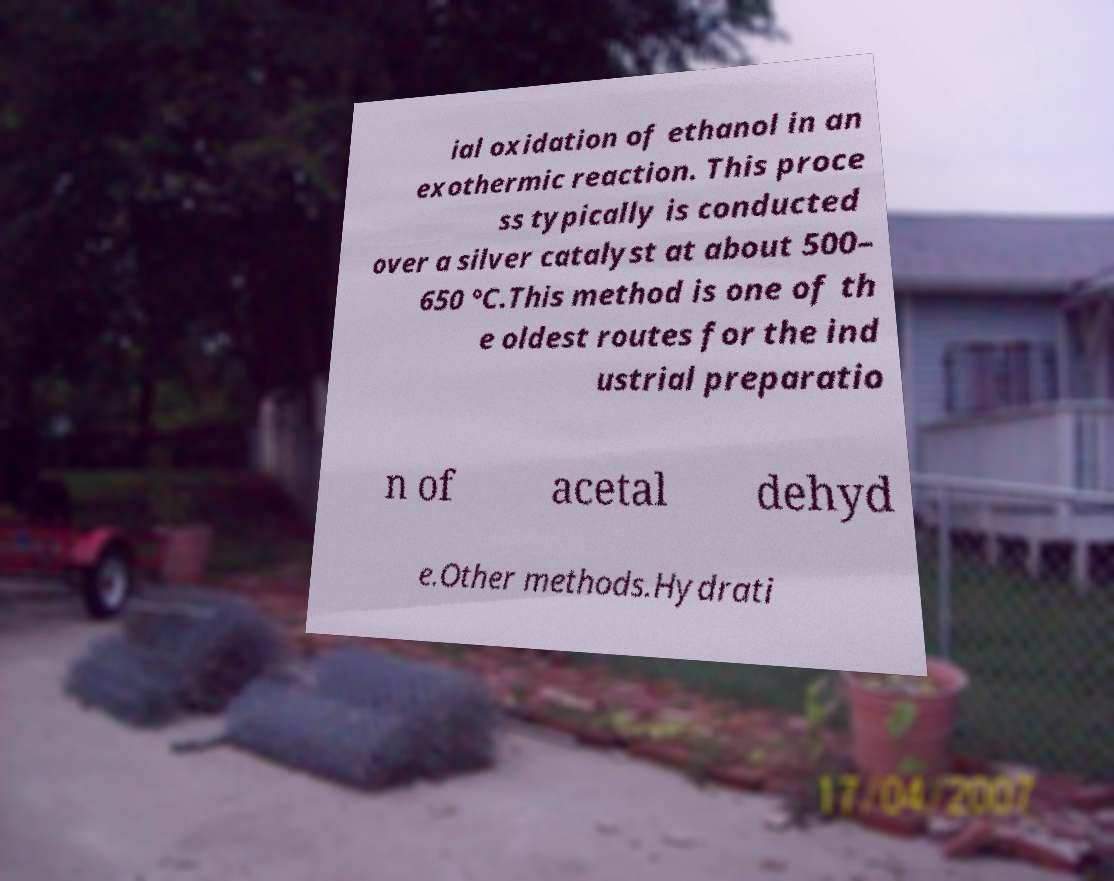For documentation purposes, I need the text within this image transcribed. Could you provide that? ial oxidation of ethanol in an exothermic reaction. This proce ss typically is conducted over a silver catalyst at about 500– 650 °C.This method is one of th e oldest routes for the ind ustrial preparatio n of acetal dehyd e.Other methods.Hydrati 